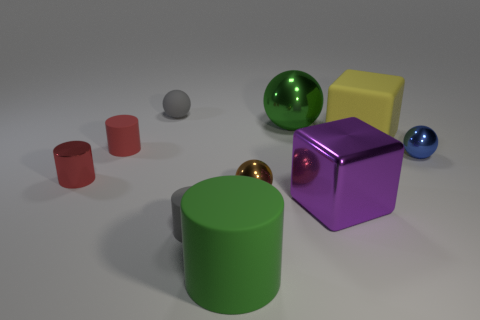Subtract all brown shiny balls. How many balls are left? 3 Subtract all yellow cubes. How many red cylinders are left? 2 Subtract all purple cubes. How many cubes are left? 1 Subtract 2 balls. How many balls are left? 2 Add 8 small purple metal spheres. How many small purple metal spheres exist? 8 Subtract 0 blue cylinders. How many objects are left? 10 Subtract all cylinders. How many objects are left? 6 Subtract all cyan balls. Subtract all red blocks. How many balls are left? 4 Subtract all tiny red rubber cylinders. Subtract all tiny objects. How many objects are left? 3 Add 4 big yellow things. How many big yellow things are left? 5 